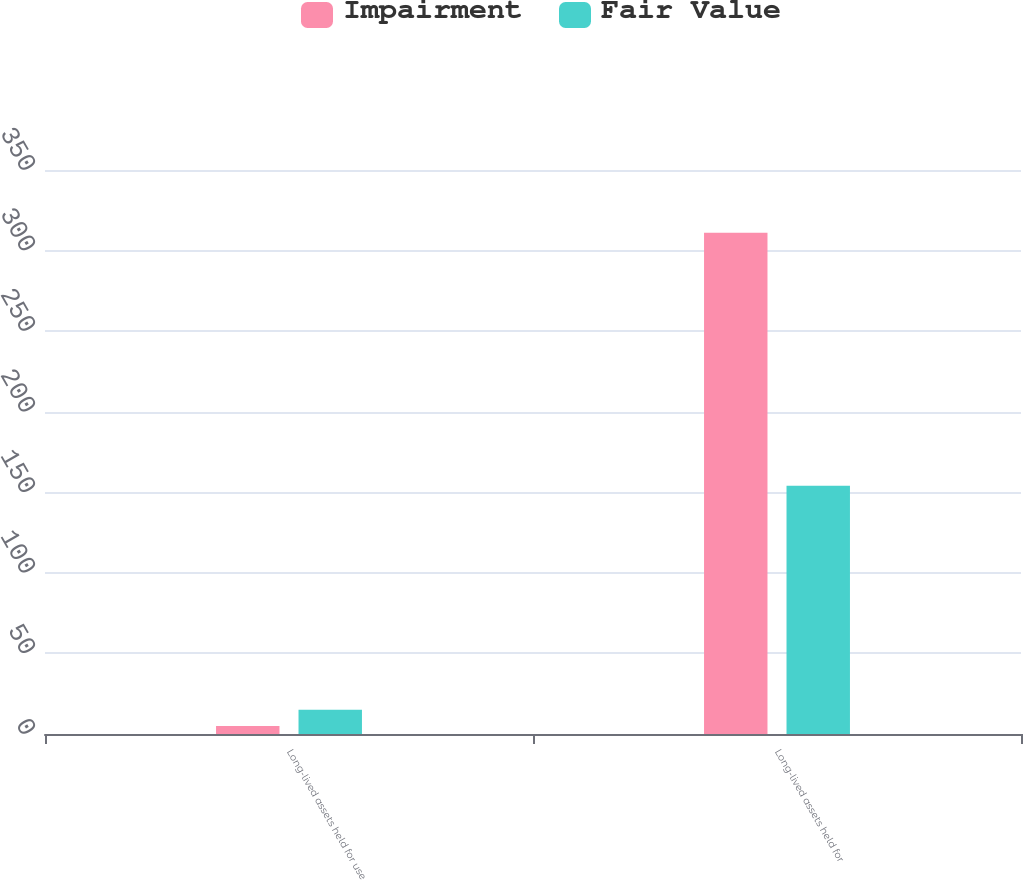Convert chart to OTSL. <chart><loc_0><loc_0><loc_500><loc_500><stacked_bar_chart><ecel><fcel>Long-lived assets held for use<fcel>Long-lived assets held for<nl><fcel>Impairment<fcel>5<fcel>311<nl><fcel>Fair Value<fcel>15<fcel>154<nl></chart> 